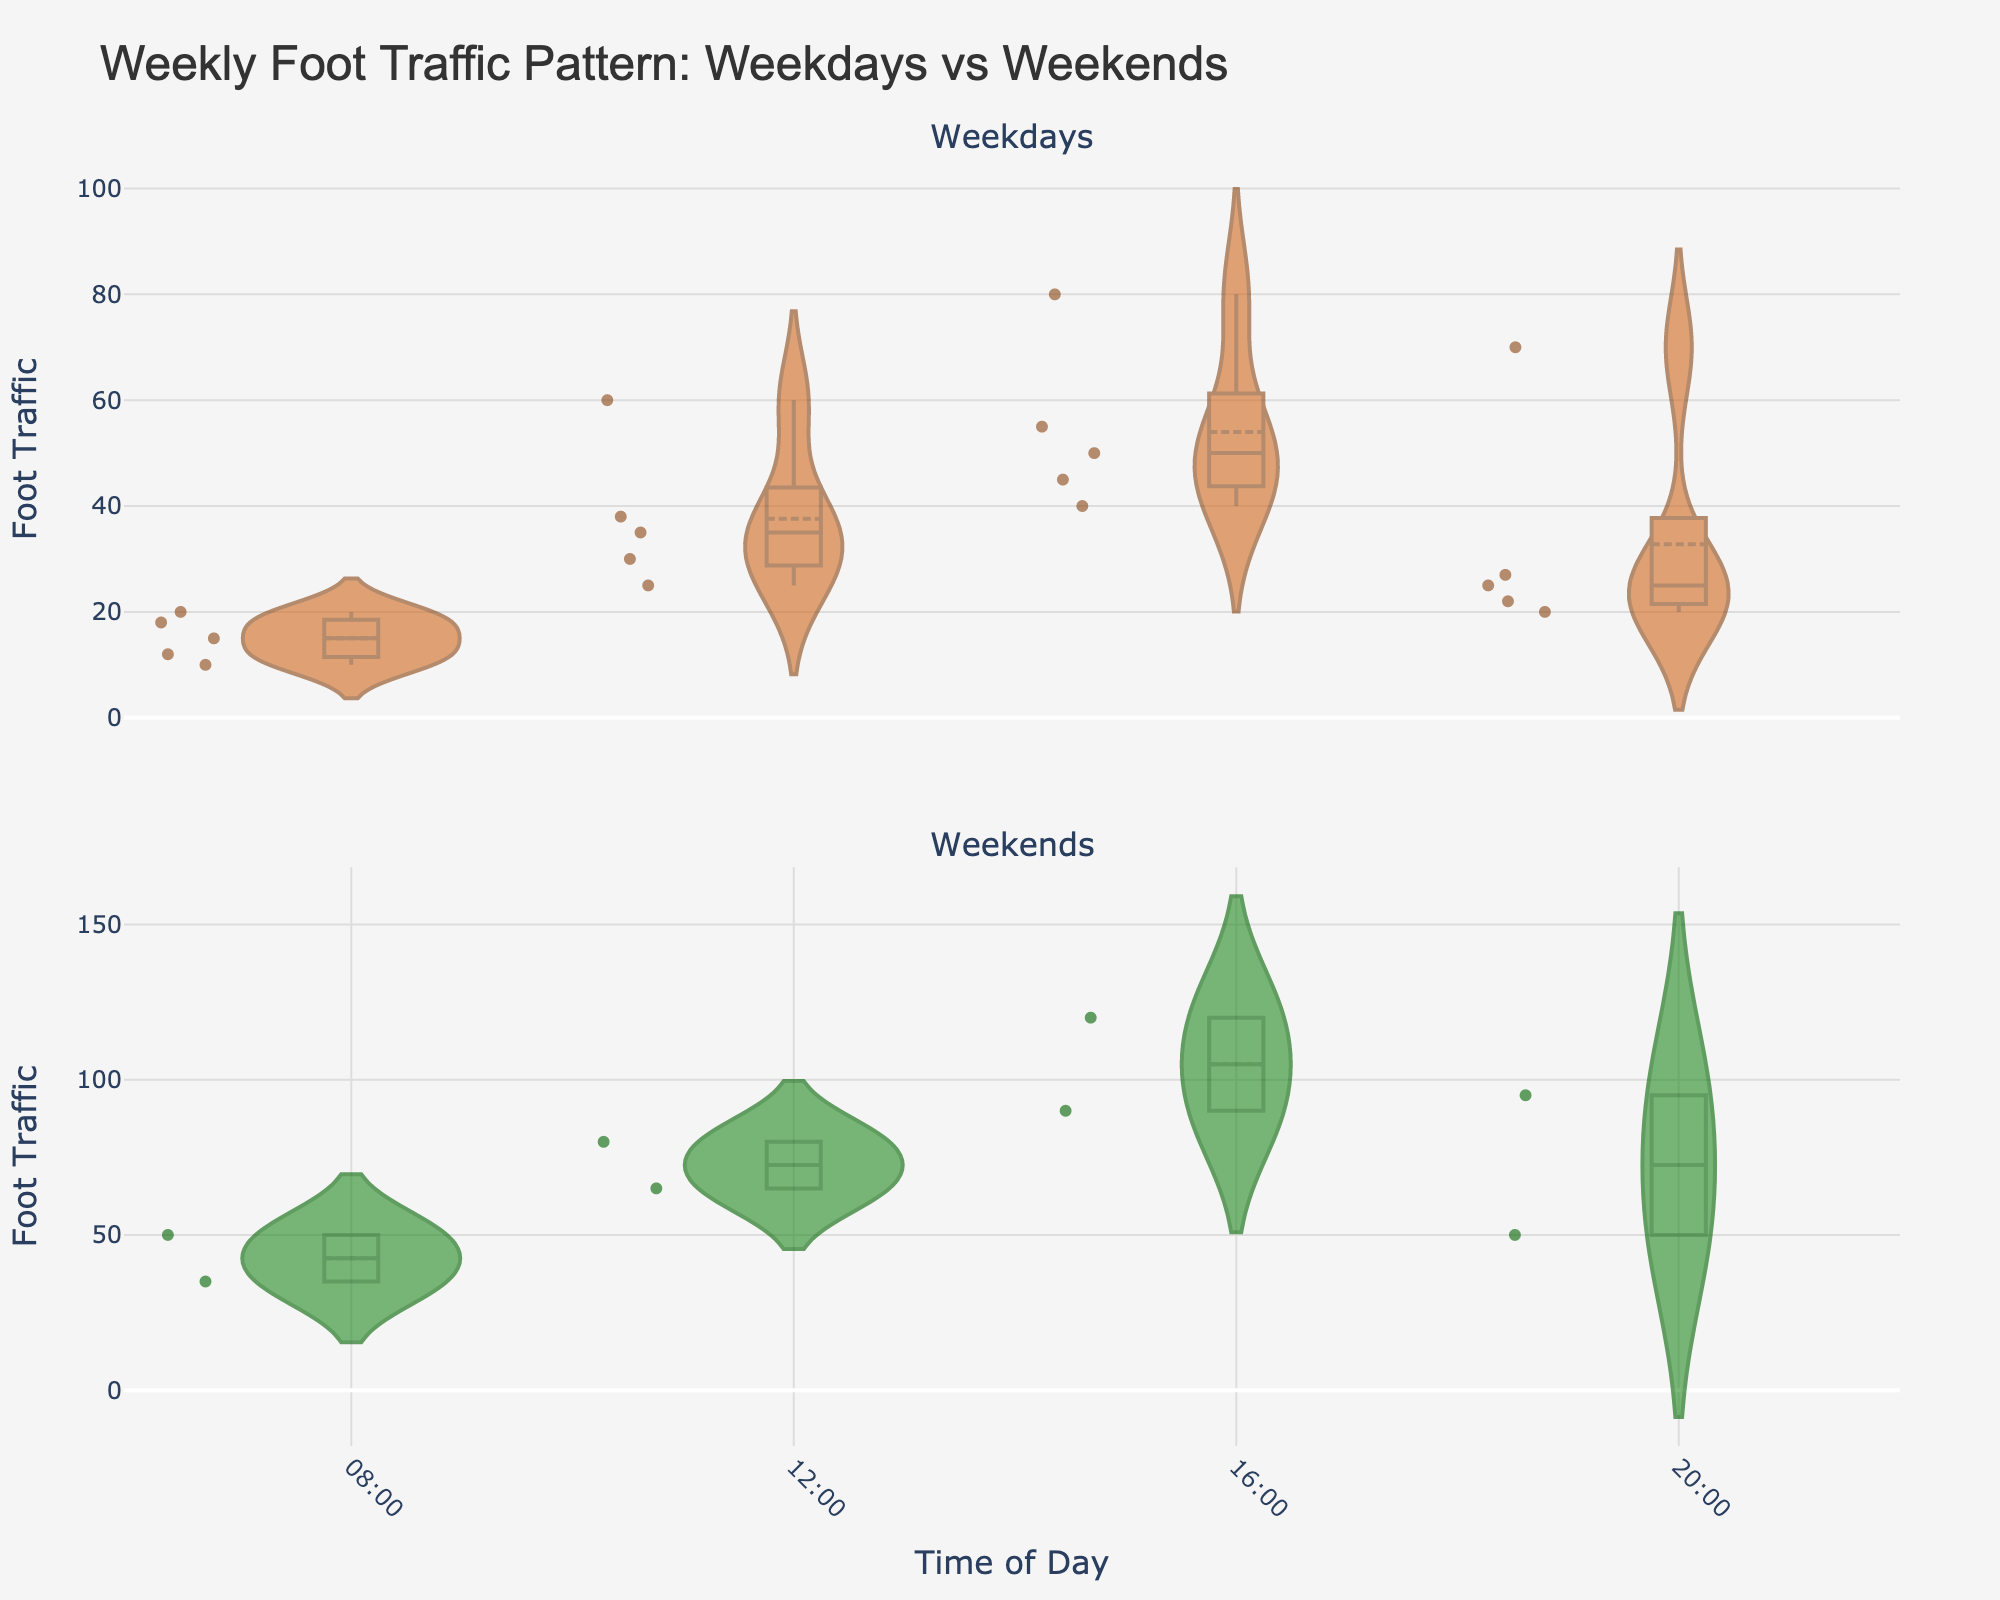What is the title of the figure? The title is generally located at the top of the figure in large, bold text. The title clearly states the subject of the visualization, which in this case is the foot traffic pattern comparing weekdays and weekends.
Answer: Weekly Foot Traffic Pattern: Weekdays vs Weekends How does foot traffic during weekdays compare with weekends in the morning? To answer this, examine the top subplot for weekdays and the bottom subplot for weekends focusing on the segment from 08:00. Compare the density and number of data points around this time.
Answer: Generally higher on weekends Which day has the highest foot traffic in the afternoon (16:00)? Look at the 16:00 time slot in both subplots and identify the tallest violin plot. The highest value within these plots will indicate the day with the most significant foot traffic in the afternoon.
Answer: Saturday Is the foot traffic at 20:00 more consistent on weekdays or weekends? Consistency can be inferred from the variability in the density plot thickness. Narrower plots indicate more consistent data. Compare the size of the violin plots in the 20:00 time slot for both subplots.
Answer: Weekdays What time of day generally shows the highest foot traffic overall? Identify the widest or highest points in the density plots across all times of the day in both subplots. Look for the time slot that consistently has higher values across both the weekday and weekend data.
Answer: 16:00 What color represents weekends in the figure? The color representing weekends can be found by examining the bottom subplot. It is a dark greenish color with a varying shade that includes points and mean lines.
Answer: Green Does the figure show more variability in foot traffic for weekdays or weekends? Greater variability will be represented by violin plots that are broader or have more scattered points. Examine the overall shape and spread of both the weekday and weekend plots.
Answer: Weekends Which periods see significant peaks in foot traffic during weekdays? Significant peaks appear as the tallest violin plots. In the top subplot (weekdays), identify the time of day with the highest peaks.
Answer: 16:00 and 12:00 What do the vertical lines within each violin plot signify? Vertical lines within violin plots usually indicate the mean or median values. The figure's layout suggests these are the means based on symmetrical placement and shading.
Answer: Mean values Is there a noticeable difference in foot traffic between weekdays and weekends during lunchtime (12:00)? Compare the violin plots at 12:00 for both subplots. The widths and heights of these plots indicate the level of foot traffic.
Answer: Yes, weekends are higher 